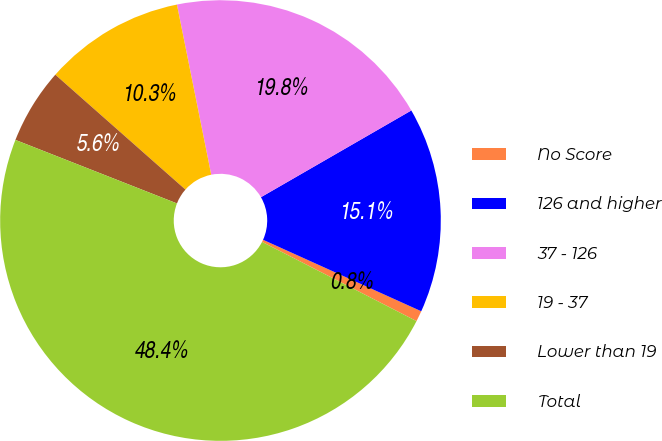<chart> <loc_0><loc_0><loc_500><loc_500><pie_chart><fcel>No Score<fcel>126 and higher<fcel>37 - 126<fcel>19 - 37<fcel>Lower than 19<fcel>Total<nl><fcel>0.79%<fcel>15.08%<fcel>19.84%<fcel>10.32%<fcel>5.55%<fcel>48.42%<nl></chart> 